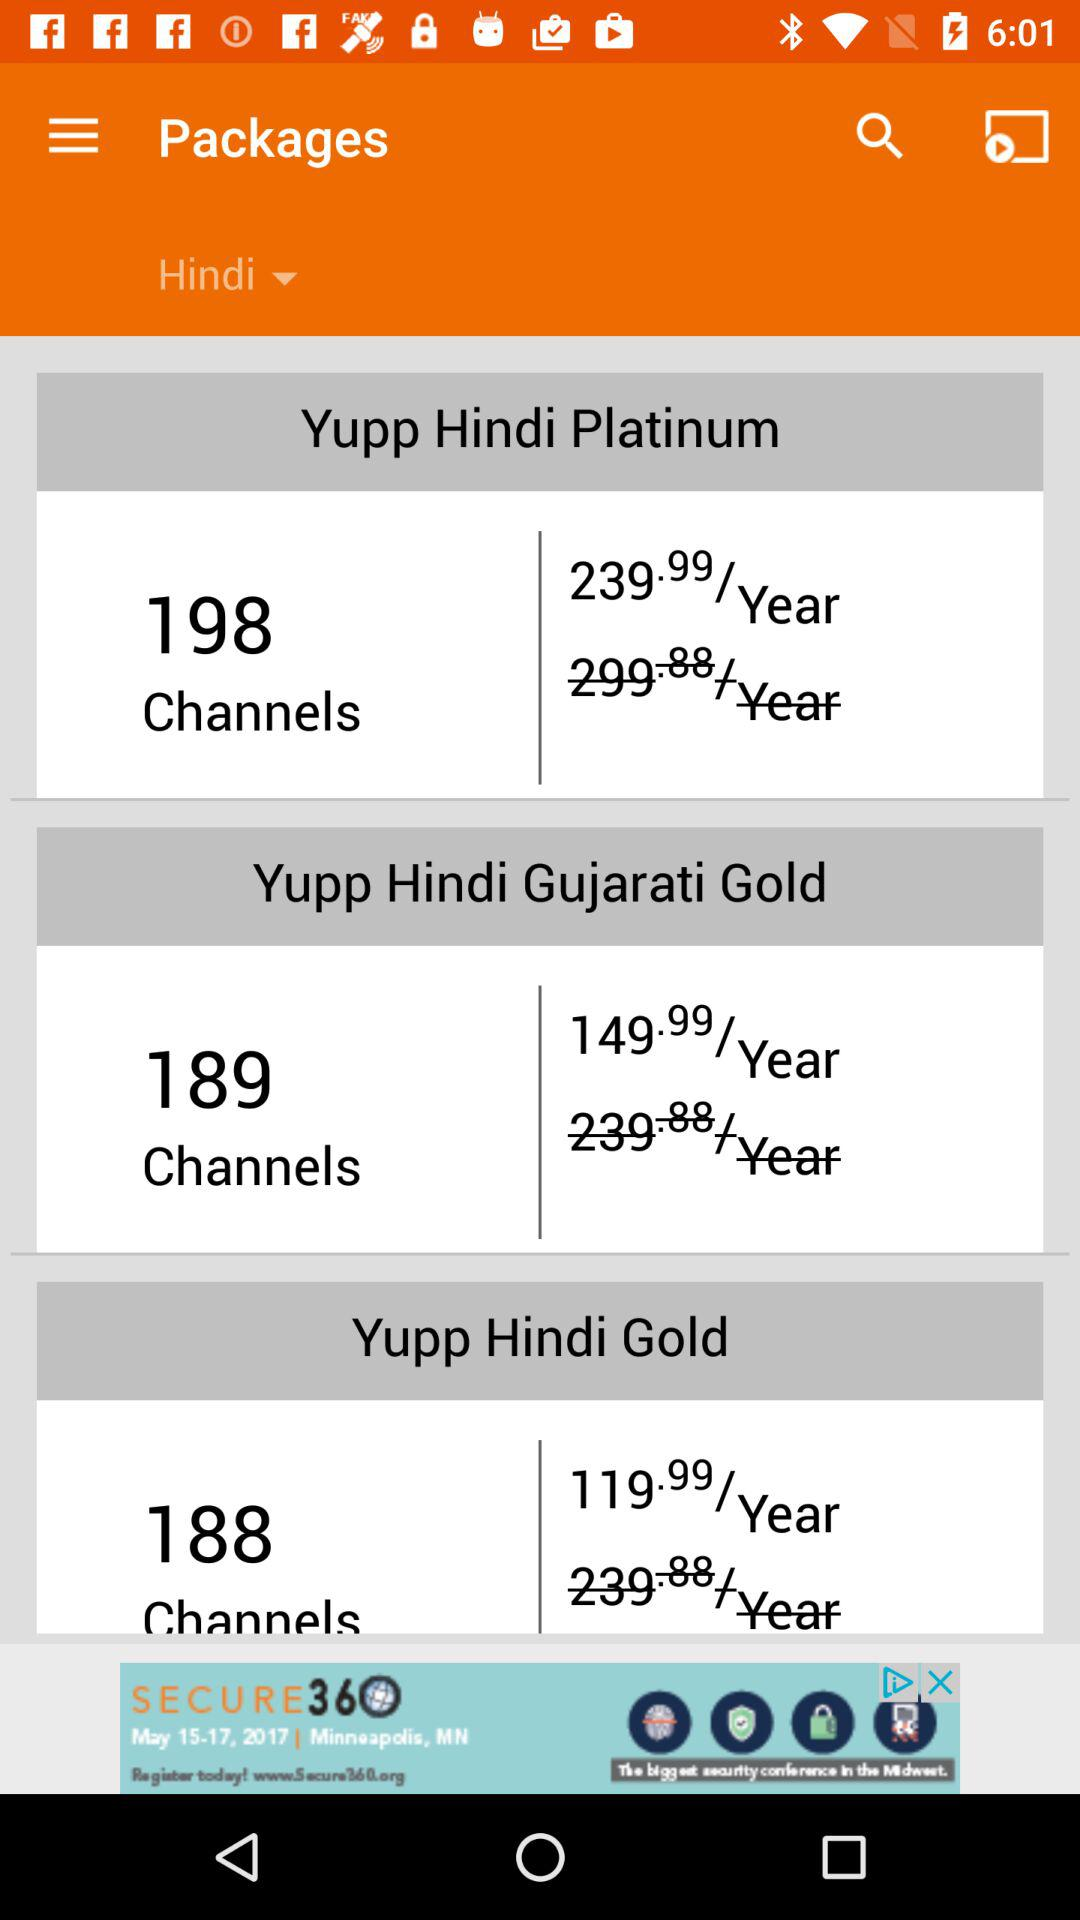How many packages are there in total?
Answer the question using a single word or phrase. 3 